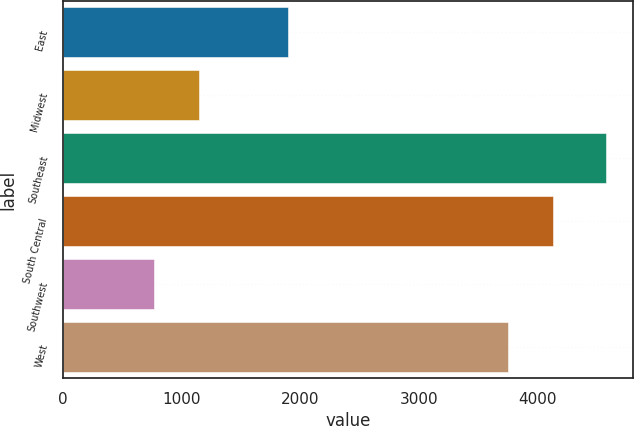Convert chart to OTSL. <chart><loc_0><loc_0><loc_500><loc_500><bar_chart><fcel>East<fcel>Midwest<fcel>Southeast<fcel>South Central<fcel>Southwest<fcel>West<nl><fcel>1893.4<fcel>1149.69<fcel>4578.6<fcel>4135.29<fcel>768.7<fcel>3754.3<nl></chart> 